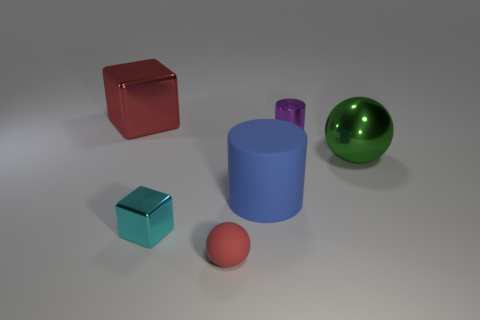What is the size of the matte object that is the same color as the large metal cube?
Offer a terse response. Small. Are there fewer large shiny things than small brown rubber things?
Your answer should be compact. No. What is the shape of the blue rubber object?
Make the answer very short. Cylinder. There is a rubber object that is in front of the tiny shiny cube; does it have the same color as the metal sphere?
Give a very brief answer. No. What is the shape of the big thing that is both in front of the purple metallic cylinder and to the left of the big sphere?
Offer a very short reply. Cylinder. There is a metal cube in front of the red metal object; what is its color?
Provide a succinct answer. Cyan. Are there any other things that have the same color as the metallic ball?
Provide a short and direct response. No. Is the size of the red block the same as the cyan block?
Give a very brief answer. No. What is the size of the object that is behind the green metallic thing and right of the tiny sphere?
Your answer should be very brief. Small. What number of tiny cyan blocks have the same material as the large cube?
Make the answer very short. 1. 